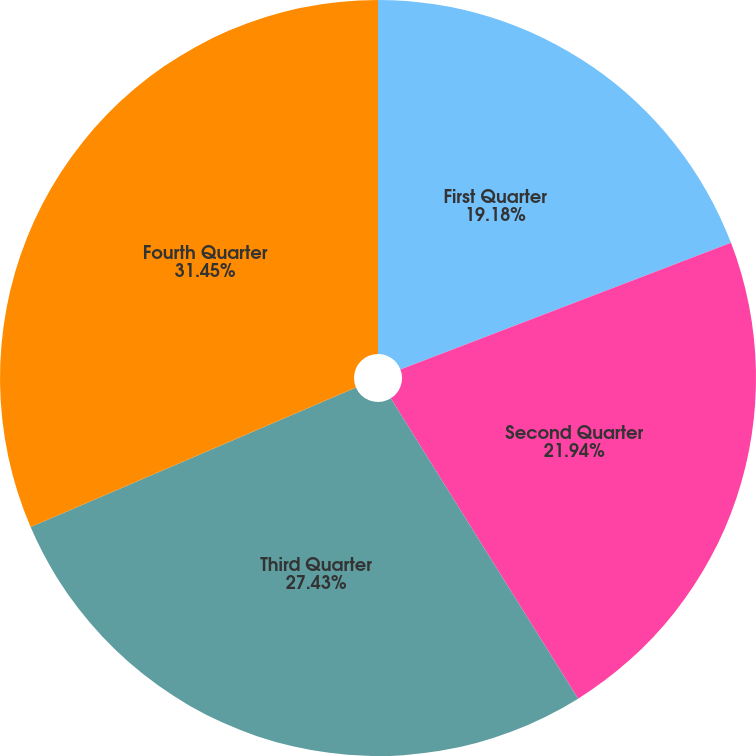<chart> <loc_0><loc_0><loc_500><loc_500><pie_chart><fcel>First Quarter<fcel>Second Quarter<fcel>Third Quarter<fcel>Fourth Quarter<nl><fcel>19.18%<fcel>21.94%<fcel>27.43%<fcel>31.45%<nl></chart> 